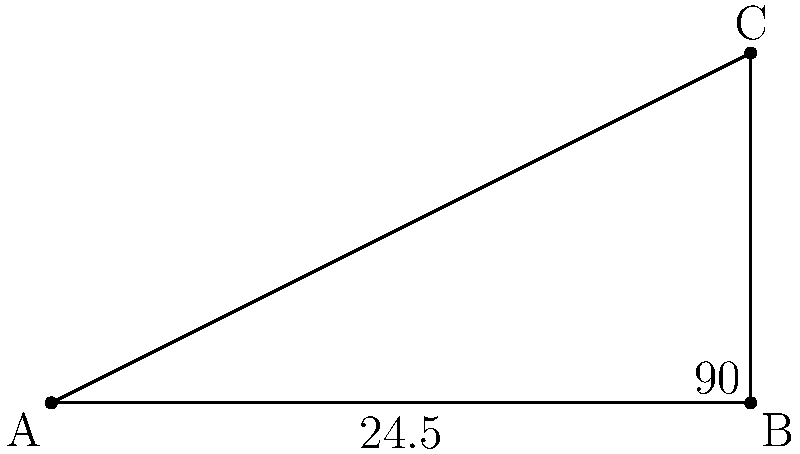A guitar has six strings, and the angle between the outermost strings when properly tuned is 24.5°. If the bridge (where the strings connect to the body of the guitar) forms a right angle with the neck, what is the angle between each adjacent pair of strings, assuming they are evenly spaced? To solve this problem, we'll follow these steps:

1) First, we need to understand that the total angle of 24.5° is divided among 5 equal spaces between the 6 strings.

2) Let's call the angle between each pair of adjacent strings $x$.

3) Since there are 5 equal spaces, we can set up the equation:
   
   $5x = 24.5°$

4) To solve for $x$, we divide both sides by 5:
   
   $x = 24.5° ÷ 5 = 4.9°$

5) We can verify this result:
   $4.9° × 5 = 24.5°$

Therefore, the angle between each adjacent pair of strings is 4.9°.
Answer: $4.9°$ 